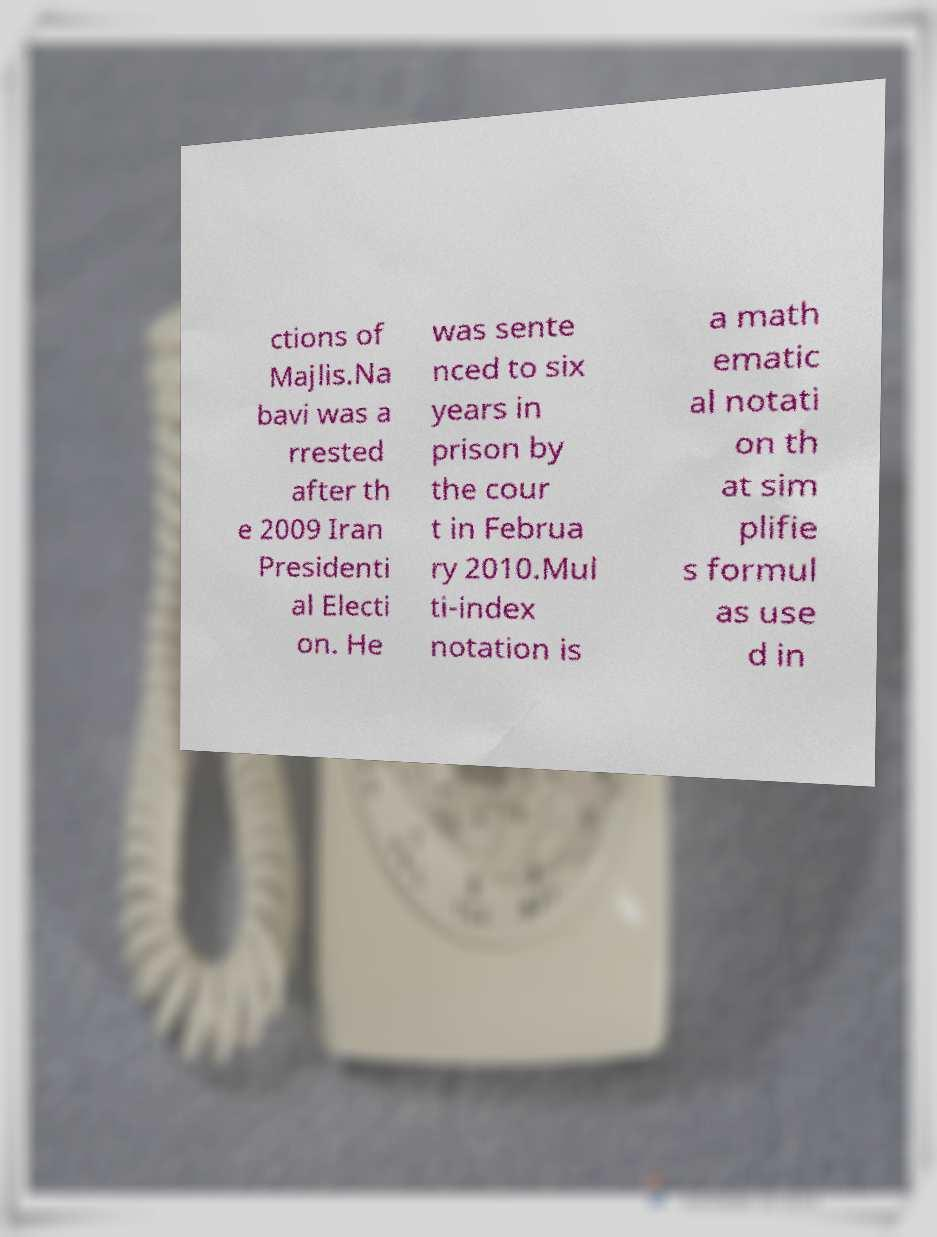Can you read and provide the text displayed in the image?This photo seems to have some interesting text. Can you extract and type it out for me? ctions of Majlis.Na bavi was a rrested after th e 2009 Iran Presidenti al Electi on. He was sente nced to six years in prison by the cour t in Februa ry 2010.Mul ti-index notation is a math ematic al notati on th at sim plifie s formul as use d in 